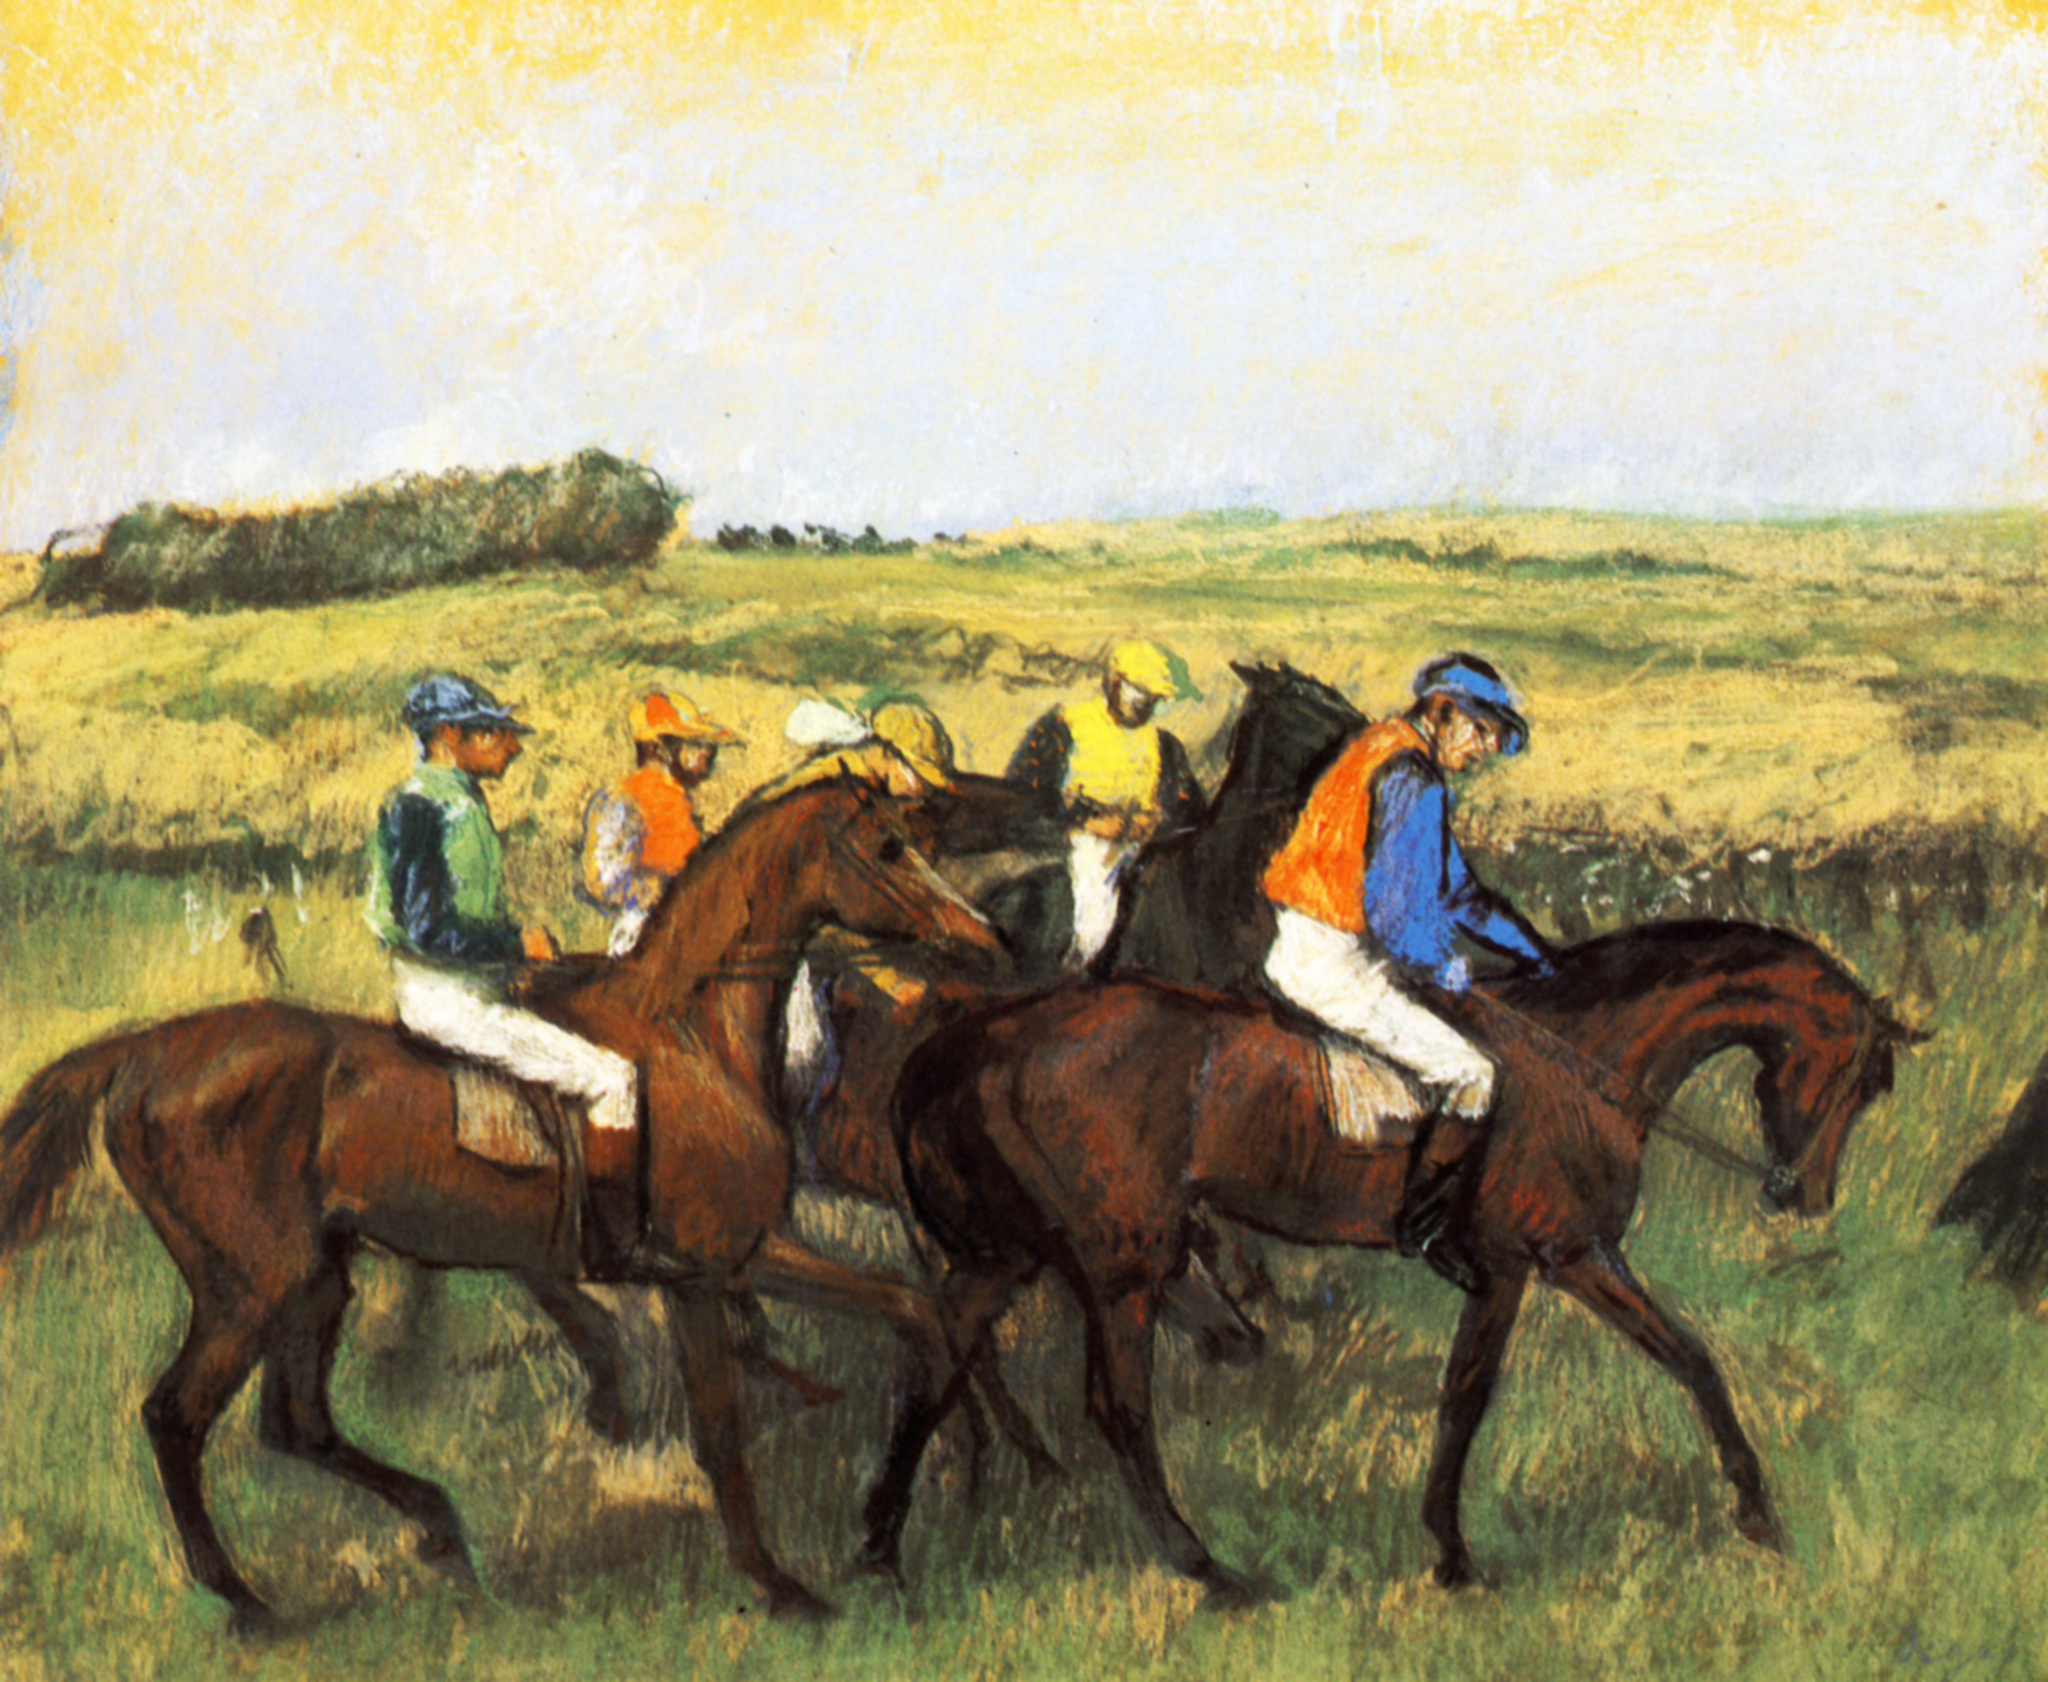What might be the significance of the colors chosen for the jockeys' uniforms? In horse racing, jockeys' silks are not only practical for identifying competitors during a race but also often carry symbolic meanings. Bright, varied colors can represent team or sponsor colors, and sometimes they are rich in personal or historical significance connected to the owner or the training team. In the context of this painting, the use of diverse, bold colors serves to enhance visual interest and guides the viewer's eye through the canvas, creating a lively and engaging scene that captures the competitive spirit and traditional pageantry of horse racing. 